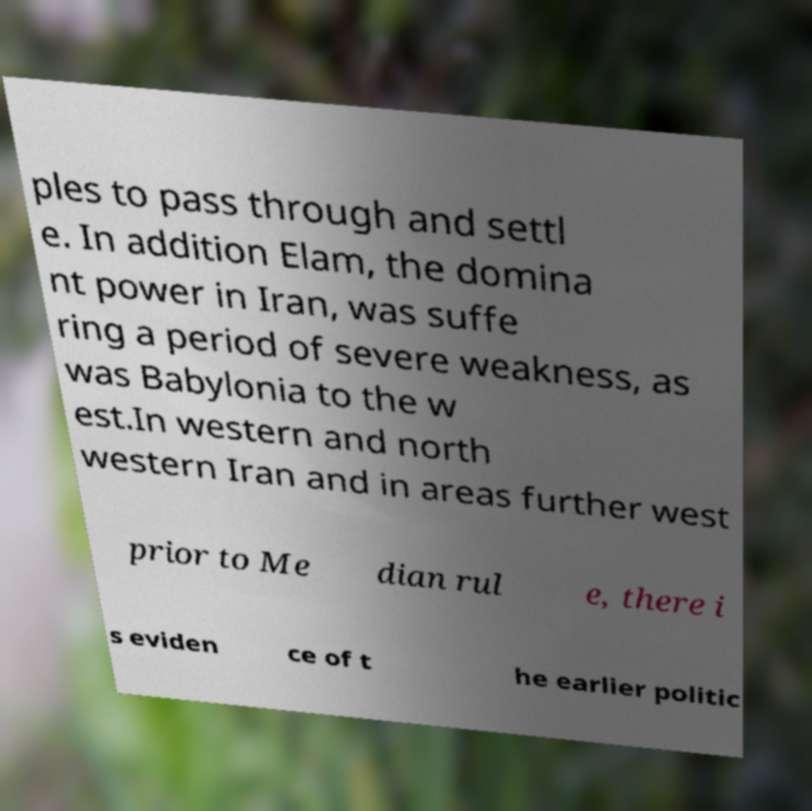For documentation purposes, I need the text within this image transcribed. Could you provide that? ples to pass through and settl e. In addition Elam, the domina nt power in Iran, was suffe ring a period of severe weakness, as was Babylonia to the w est.In western and north western Iran and in areas further west prior to Me dian rul e, there i s eviden ce of t he earlier politic 